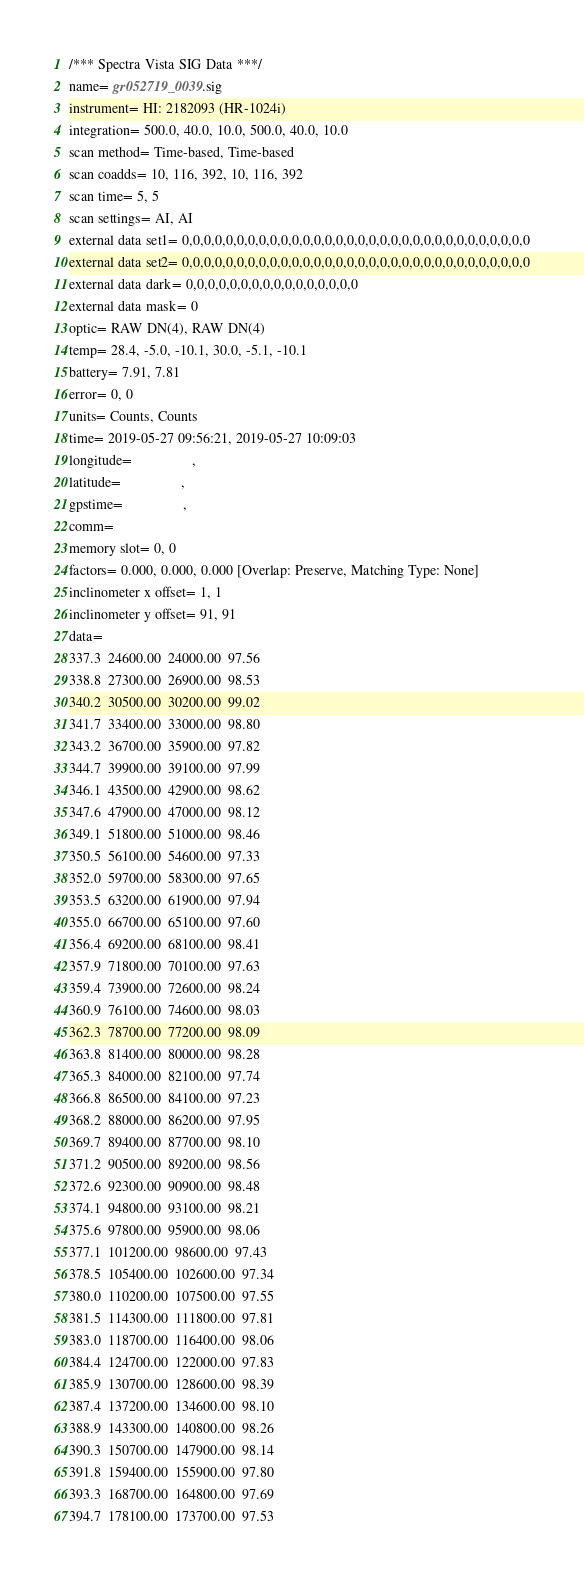Convert code to text. <code><loc_0><loc_0><loc_500><loc_500><_SML_>/*** Spectra Vista SIG Data ***/
name= gr052719_0039.sig
instrument= HI: 2182093 (HR-1024i)
integration= 500.0, 40.0, 10.0, 500.0, 40.0, 10.0
scan method= Time-based, Time-based
scan coadds= 10, 116, 392, 10, 116, 392
scan time= 5, 5
scan settings= AI, AI
external data set1= 0,0,0,0,0,0,0,0,0,0,0,0,0,0,0,0,0,0,0,0,0,0,0,0,0,0,0,0,0,0,0,0
external data set2= 0,0,0,0,0,0,0,0,0,0,0,0,0,0,0,0,0,0,0,0,0,0,0,0,0,0,0,0,0,0,0,0
external data dark= 0,0,0,0,0,0,0,0,0,0,0,0,0,0,0,0
external data mask= 0
optic= RAW DN(4), RAW DN(4)
temp= 28.4, -5.0, -10.1, 30.0, -5.1, -10.1
battery= 7.91, 7.81
error= 0, 0
units= Counts, Counts
time= 2019-05-27 09:56:21, 2019-05-27 10:09:03
longitude=                 ,                 
latitude=                 ,                 
gpstime=                 ,                 
comm= 
memory slot= 0, 0
factors= 0.000, 0.000, 0.000 [Overlap: Preserve, Matching Type: None]
inclinometer x offset= 1, 1
inclinometer y offset= 91, 91
data= 
337.3  24600.00  24000.00  97.56
338.8  27300.00  26900.00  98.53
340.2  30500.00  30200.00  99.02
341.7  33400.00  33000.00  98.80
343.2  36700.00  35900.00  97.82
344.7  39900.00  39100.00  97.99
346.1  43500.00  42900.00  98.62
347.6  47900.00  47000.00  98.12
349.1  51800.00  51000.00  98.46
350.5  56100.00  54600.00  97.33
352.0  59700.00  58300.00  97.65
353.5  63200.00  61900.00  97.94
355.0  66700.00  65100.00  97.60
356.4  69200.00  68100.00  98.41
357.9  71800.00  70100.00  97.63
359.4  73900.00  72600.00  98.24
360.9  76100.00  74600.00  98.03
362.3  78700.00  77200.00  98.09
363.8  81400.00  80000.00  98.28
365.3  84000.00  82100.00  97.74
366.8  86500.00  84100.00  97.23
368.2  88000.00  86200.00  97.95
369.7  89400.00  87700.00  98.10
371.2  90500.00  89200.00  98.56
372.6  92300.00  90900.00  98.48
374.1  94800.00  93100.00  98.21
375.6  97800.00  95900.00  98.06
377.1  101200.00  98600.00  97.43
378.5  105400.00  102600.00  97.34
380.0  110200.00  107500.00  97.55
381.5  114300.00  111800.00  97.81
383.0  118700.00  116400.00  98.06
384.4  124700.00  122000.00  97.83
385.9  130700.00  128600.00  98.39
387.4  137200.00  134600.00  98.10
388.9  143300.00  140800.00  98.26
390.3  150700.00  147900.00  98.14
391.8  159400.00  155900.00  97.80
393.3  168700.00  164800.00  97.69
394.7  178100.00  173700.00  97.53</code> 